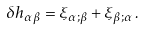<formula> <loc_0><loc_0><loc_500><loc_500>\delta h _ { \alpha \beta } = \xi _ { \alpha ; \beta } + \xi _ { \beta ; \alpha } \, .</formula> 